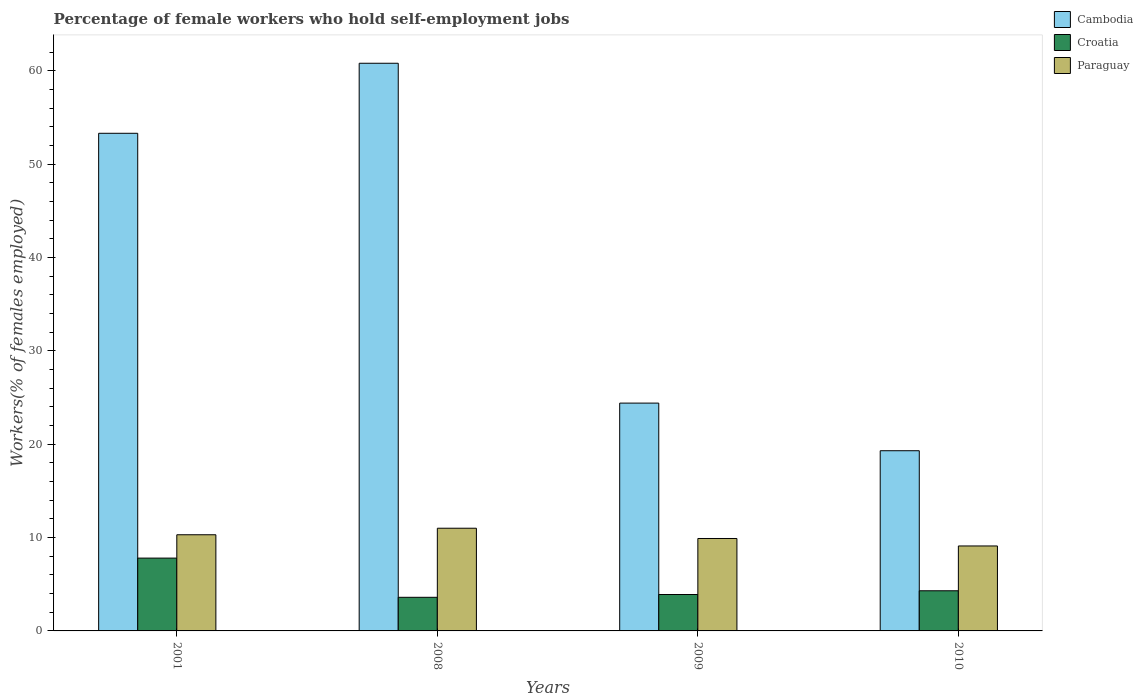How many different coloured bars are there?
Your response must be concise. 3. Are the number of bars per tick equal to the number of legend labels?
Ensure brevity in your answer.  Yes. Are the number of bars on each tick of the X-axis equal?
Your answer should be compact. Yes. What is the label of the 3rd group of bars from the left?
Ensure brevity in your answer.  2009. What is the percentage of self-employed female workers in Cambodia in 2009?
Provide a short and direct response. 24.4. Across all years, what is the maximum percentage of self-employed female workers in Cambodia?
Your answer should be compact. 60.8. Across all years, what is the minimum percentage of self-employed female workers in Croatia?
Provide a short and direct response. 3.6. In which year was the percentage of self-employed female workers in Croatia maximum?
Provide a succinct answer. 2001. What is the total percentage of self-employed female workers in Paraguay in the graph?
Give a very brief answer. 40.3. What is the difference between the percentage of self-employed female workers in Croatia in 2001 and that in 2010?
Your answer should be very brief. 3.5. What is the difference between the percentage of self-employed female workers in Cambodia in 2010 and the percentage of self-employed female workers in Croatia in 2009?
Provide a succinct answer. 15.4. What is the average percentage of self-employed female workers in Croatia per year?
Provide a short and direct response. 4.9. In the year 2008, what is the difference between the percentage of self-employed female workers in Paraguay and percentage of self-employed female workers in Cambodia?
Give a very brief answer. -49.8. In how many years, is the percentage of self-employed female workers in Paraguay greater than 28 %?
Your answer should be compact. 0. What is the ratio of the percentage of self-employed female workers in Cambodia in 2008 to that in 2009?
Make the answer very short. 2.49. What is the difference between the highest and the second highest percentage of self-employed female workers in Cambodia?
Make the answer very short. 7.5. What is the difference between the highest and the lowest percentage of self-employed female workers in Cambodia?
Keep it short and to the point. 41.5. Is the sum of the percentage of self-employed female workers in Cambodia in 2001 and 2010 greater than the maximum percentage of self-employed female workers in Croatia across all years?
Offer a very short reply. Yes. What does the 3rd bar from the left in 2008 represents?
Ensure brevity in your answer.  Paraguay. What does the 2nd bar from the right in 2010 represents?
Provide a succinct answer. Croatia. How many years are there in the graph?
Offer a very short reply. 4. Are the values on the major ticks of Y-axis written in scientific E-notation?
Provide a short and direct response. No. Does the graph contain grids?
Keep it short and to the point. No. What is the title of the graph?
Provide a succinct answer. Percentage of female workers who hold self-employment jobs. What is the label or title of the Y-axis?
Ensure brevity in your answer.  Workers(% of females employed). What is the Workers(% of females employed) of Cambodia in 2001?
Make the answer very short. 53.3. What is the Workers(% of females employed) of Croatia in 2001?
Offer a terse response. 7.8. What is the Workers(% of females employed) of Paraguay in 2001?
Your answer should be compact. 10.3. What is the Workers(% of females employed) in Cambodia in 2008?
Your response must be concise. 60.8. What is the Workers(% of females employed) of Croatia in 2008?
Your answer should be compact. 3.6. What is the Workers(% of females employed) in Cambodia in 2009?
Your response must be concise. 24.4. What is the Workers(% of females employed) of Croatia in 2009?
Give a very brief answer. 3.9. What is the Workers(% of females employed) of Paraguay in 2009?
Your response must be concise. 9.9. What is the Workers(% of females employed) in Cambodia in 2010?
Make the answer very short. 19.3. What is the Workers(% of females employed) in Croatia in 2010?
Ensure brevity in your answer.  4.3. What is the Workers(% of females employed) in Paraguay in 2010?
Offer a very short reply. 9.1. Across all years, what is the maximum Workers(% of females employed) of Cambodia?
Provide a succinct answer. 60.8. Across all years, what is the maximum Workers(% of females employed) in Croatia?
Keep it short and to the point. 7.8. Across all years, what is the maximum Workers(% of females employed) of Paraguay?
Your response must be concise. 11. Across all years, what is the minimum Workers(% of females employed) in Cambodia?
Your answer should be compact. 19.3. Across all years, what is the minimum Workers(% of females employed) of Croatia?
Make the answer very short. 3.6. Across all years, what is the minimum Workers(% of females employed) in Paraguay?
Your answer should be compact. 9.1. What is the total Workers(% of females employed) in Cambodia in the graph?
Your response must be concise. 157.8. What is the total Workers(% of females employed) in Croatia in the graph?
Offer a very short reply. 19.6. What is the total Workers(% of females employed) of Paraguay in the graph?
Provide a short and direct response. 40.3. What is the difference between the Workers(% of females employed) of Paraguay in 2001 and that in 2008?
Offer a terse response. -0.7. What is the difference between the Workers(% of females employed) in Cambodia in 2001 and that in 2009?
Provide a succinct answer. 28.9. What is the difference between the Workers(% of females employed) in Croatia in 2001 and that in 2009?
Provide a short and direct response. 3.9. What is the difference between the Workers(% of females employed) in Cambodia in 2001 and that in 2010?
Give a very brief answer. 34. What is the difference between the Workers(% of females employed) in Paraguay in 2001 and that in 2010?
Make the answer very short. 1.2. What is the difference between the Workers(% of females employed) in Cambodia in 2008 and that in 2009?
Ensure brevity in your answer.  36.4. What is the difference between the Workers(% of females employed) of Croatia in 2008 and that in 2009?
Make the answer very short. -0.3. What is the difference between the Workers(% of females employed) of Paraguay in 2008 and that in 2009?
Your response must be concise. 1.1. What is the difference between the Workers(% of females employed) in Cambodia in 2008 and that in 2010?
Give a very brief answer. 41.5. What is the difference between the Workers(% of females employed) in Croatia in 2008 and that in 2010?
Your answer should be compact. -0.7. What is the difference between the Workers(% of females employed) in Paraguay in 2008 and that in 2010?
Provide a succinct answer. 1.9. What is the difference between the Workers(% of females employed) of Cambodia in 2009 and that in 2010?
Give a very brief answer. 5.1. What is the difference between the Workers(% of females employed) in Cambodia in 2001 and the Workers(% of females employed) in Croatia in 2008?
Keep it short and to the point. 49.7. What is the difference between the Workers(% of females employed) of Cambodia in 2001 and the Workers(% of females employed) of Paraguay in 2008?
Give a very brief answer. 42.3. What is the difference between the Workers(% of females employed) in Cambodia in 2001 and the Workers(% of females employed) in Croatia in 2009?
Ensure brevity in your answer.  49.4. What is the difference between the Workers(% of females employed) of Cambodia in 2001 and the Workers(% of females employed) of Paraguay in 2009?
Offer a very short reply. 43.4. What is the difference between the Workers(% of females employed) in Cambodia in 2001 and the Workers(% of females employed) in Croatia in 2010?
Provide a succinct answer. 49. What is the difference between the Workers(% of females employed) in Cambodia in 2001 and the Workers(% of females employed) in Paraguay in 2010?
Make the answer very short. 44.2. What is the difference between the Workers(% of females employed) in Croatia in 2001 and the Workers(% of females employed) in Paraguay in 2010?
Keep it short and to the point. -1.3. What is the difference between the Workers(% of females employed) in Cambodia in 2008 and the Workers(% of females employed) in Croatia in 2009?
Your answer should be compact. 56.9. What is the difference between the Workers(% of females employed) of Cambodia in 2008 and the Workers(% of females employed) of Paraguay in 2009?
Your answer should be compact. 50.9. What is the difference between the Workers(% of females employed) in Cambodia in 2008 and the Workers(% of females employed) in Croatia in 2010?
Give a very brief answer. 56.5. What is the difference between the Workers(% of females employed) in Cambodia in 2008 and the Workers(% of females employed) in Paraguay in 2010?
Give a very brief answer. 51.7. What is the difference between the Workers(% of females employed) in Cambodia in 2009 and the Workers(% of females employed) in Croatia in 2010?
Keep it short and to the point. 20.1. What is the average Workers(% of females employed) of Cambodia per year?
Keep it short and to the point. 39.45. What is the average Workers(% of females employed) in Paraguay per year?
Keep it short and to the point. 10.07. In the year 2001, what is the difference between the Workers(% of females employed) of Cambodia and Workers(% of females employed) of Croatia?
Offer a very short reply. 45.5. In the year 2001, what is the difference between the Workers(% of females employed) of Cambodia and Workers(% of females employed) of Paraguay?
Offer a terse response. 43. In the year 2008, what is the difference between the Workers(% of females employed) of Cambodia and Workers(% of females employed) of Croatia?
Offer a very short reply. 57.2. In the year 2008, what is the difference between the Workers(% of females employed) in Cambodia and Workers(% of females employed) in Paraguay?
Provide a succinct answer. 49.8. In the year 2009, what is the difference between the Workers(% of females employed) in Cambodia and Workers(% of females employed) in Croatia?
Offer a very short reply. 20.5. In the year 2009, what is the difference between the Workers(% of females employed) in Cambodia and Workers(% of females employed) in Paraguay?
Make the answer very short. 14.5. In the year 2009, what is the difference between the Workers(% of females employed) in Croatia and Workers(% of females employed) in Paraguay?
Your answer should be compact. -6. What is the ratio of the Workers(% of females employed) in Cambodia in 2001 to that in 2008?
Make the answer very short. 0.88. What is the ratio of the Workers(% of females employed) in Croatia in 2001 to that in 2008?
Ensure brevity in your answer.  2.17. What is the ratio of the Workers(% of females employed) of Paraguay in 2001 to that in 2008?
Make the answer very short. 0.94. What is the ratio of the Workers(% of females employed) of Cambodia in 2001 to that in 2009?
Your response must be concise. 2.18. What is the ratio of the Workers(% of females employed) of Paraguay in 2001 to that in 2009?
Offer a terse response. 1.04. What is the ratio of the Workers(% of females employed) of Cambodia in 2001 to that in 2010?
Your response must be concise. 2.76. What is the ratio of the Workers(% of females employed) in Croatia in 2001 to that in 2010?
Your answer should be very brief. 1.81. What is the ratio of the Workers(% of females employed) in Paraguay in 2001 to that in 2010?
Your answer should be very brief. 1.13. What is the ratio of the Workers(% of females employed) in Cambodia in 2008 to that in 2009?
Your response must be concise. 2.49. What is the ratio of the Workers(% of females employed) of Croatia in 2008 to that in 2009?
Keep it short and to the point. 0.92. What is the ratio of the Workers(% of females employed) of Cambodia in 2008 to that in 2010?
Provide a short and direct response. 3.15. What is the ratio of the Workers(% of females employed) of Croatia in 2008 to that in 2010?
Provide a short and direct response. 0.84. What is the ratio of the Workers(% of females employed) in Paraguay in 2008 to that in 2010?
Your answer should be very brief. 1.21. What is the ratio of the Workers(% of females employed) of Cambodia in 2009 to that in 2010?
Your answer should be compact. 1.26. What is the ratio of the Workers(% of females employed) of Croatia in 2009 to that in 2010?
Make the answer very short. 0.91. What is the ratio of the Workers(% of females employed) of Paraguay in 2009 to that in 2010?
Offer a very short reply. 1.09. What is the difference between the highest and the second highest Workers(% of females employed) of Cambodia?
Your answer should be very brief. 7.5. What is the difference between the highest and the second highest Workers(% of females employed) in Paraguay?
Your answer should be very brief. 0.7. What is the difference between the highest and the lowest Workers(% of females employed) in Cambodia?
Your response must be concise. 41.5. What is the difference between the highest and the lowest Workers(% of females employed) of Croatia?
Make the answer very short. 4.2. What is the difference between the highest and the lowest Workers(% of females employed) of Paraguay?
Give a very brief answer. 1.9. 